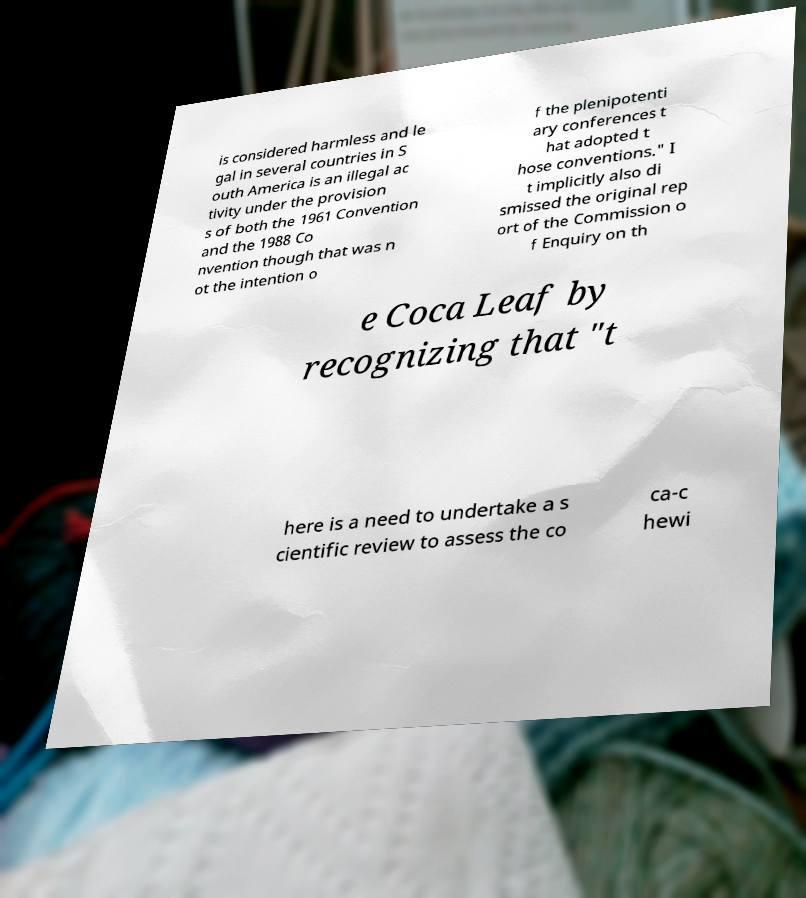There's text embedded in this image that I need extracted. Can you transcribe it verbatim? is considered harmless and le gal in several countries in S outh America is an illegal ac tivity under the provision s of both the 1961 Convention and the 1988 Co nvention though that was n ot the intention o f the plenipotenti ary conferences t hat adopted t hose conventions." I t implicitly also di smissed the original rep ort of the Commission o f Enquiry on th e Coca Leaf by recognizing that "t here is a need to undertake a s cientific review to assess the co ca-c hewi 